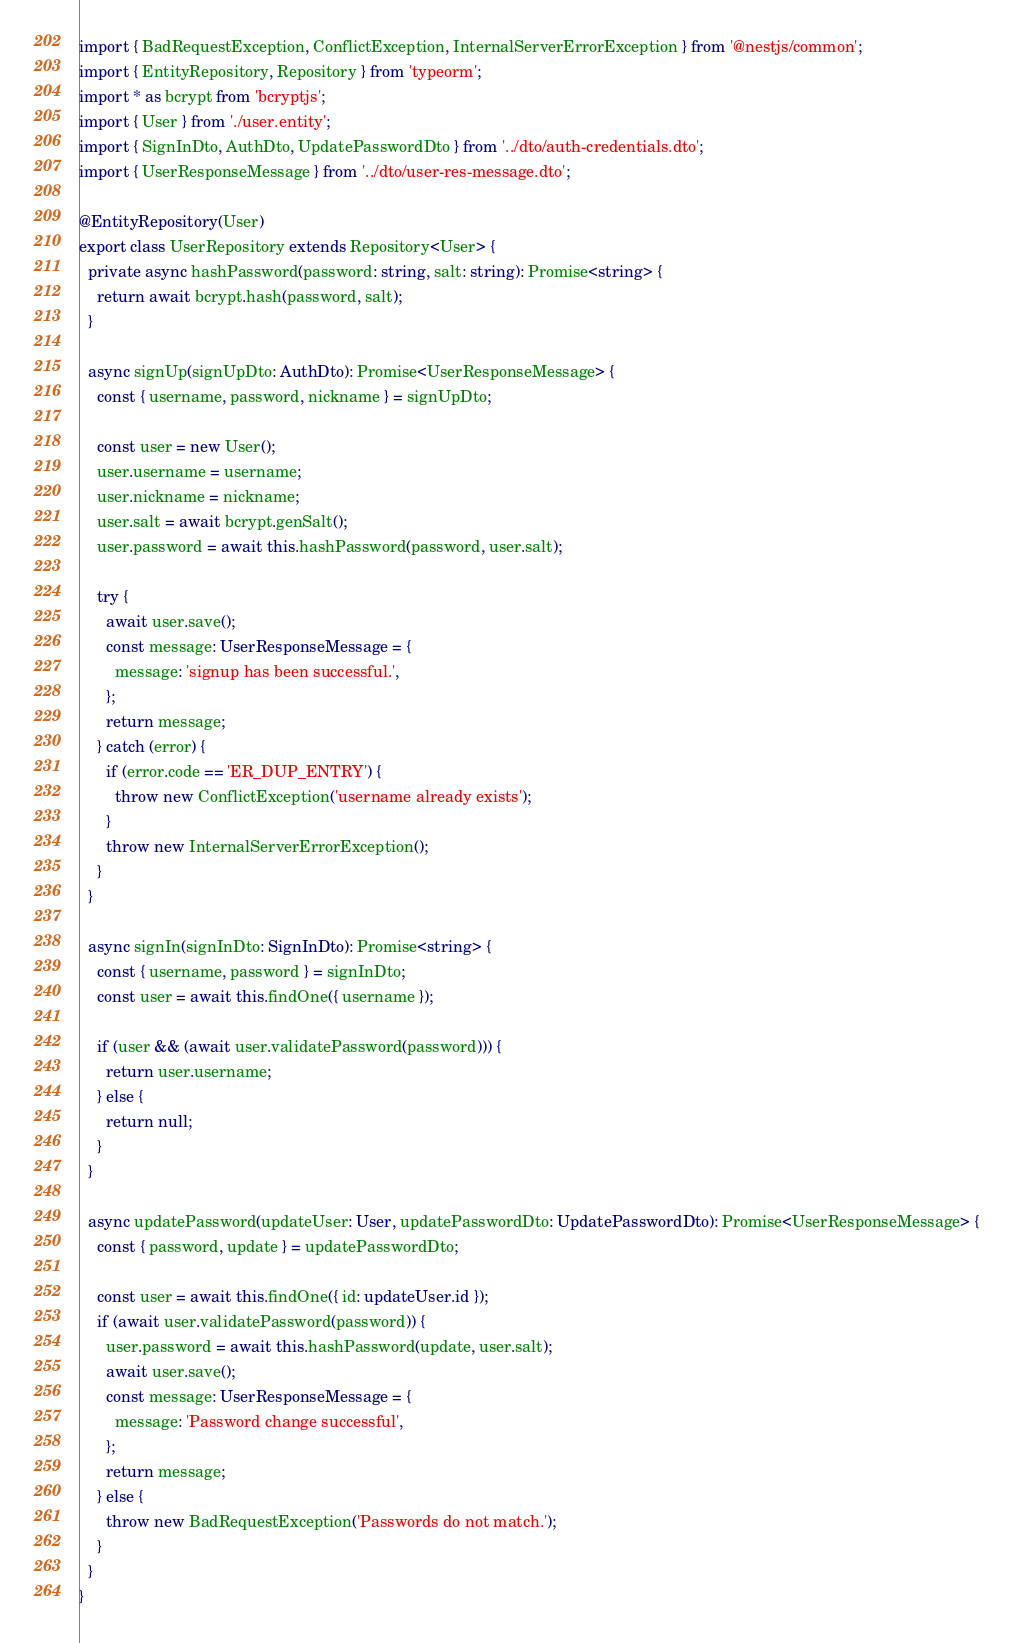<code> <loc_0><loc_0><loc_500><loc_500><_TypeScript_>import { BadRequestException, ConflictException, InternalServerErrorException } from '@nestjs/common';
import { EntityRepository, Repository } from 'typeorm';
import * as bcrypt from 'bcryptjs';
import { User } from './user.entity';
import { SignInDto, AuthDto, UpdatePasswordDto } from '../dto/auth-credentials.dto';
import { UserResponseMessage } from '../dto/user-res-message.dto';

@EntityRepository(User)
export class UserRepository extends Repository<User> {
  private async hashPassword(password: string, salt: string): Promise<string> {
    return await bcrypt.hash(password, salt);
  }

  async signUp(signUpDto: AuthDto): Promise<UserResponseMessage> {
    const { username, password, nickname } = signUpDto;

    const user = new User();
    user.username = username;
    user.nickname = nickname;
    user.salt = await bcrypt.genSalt();
    user.password = await this.hashPassword(password, user.salt);

    try {
      await user.save();
      const message: UserResponseMessage = {
        message: 'signup has been successful.',
      };
      return message;
    } catch (error) {
      if (error.code == 'ER_DUP_ENTRY') {
        throw new ConflictException('username already exists');
      }
      throw new InternalServerErrorException();
    }
  }

  async signIn(signInDto: SignInDto): Promise<string> {
    const { username, password } = signInDto;
    const user = await this.findOne({ username });

    if (user && (await user.validatePassword(password))) {
      return user.username;
    } else {
      return null;
    }
  }

  async updatePassword(updateUser: User, updatePasswordDto: UpdatePasswordDto): Promise<UserResponseMessage> {
    const { password, update } = updatePasswordDto;

    const user = await this.findOne({ id: updateUser.id });
    if (await user.validatePassword(password)) {
      user.password = await this.hashPassword(update, user.salt);
      await user.save();
      const message: UserResponseMessage = {
        message: 'Password change successful',
      };
      return message;
    } else {
      throw new BadRequestException('Passwords do not match.');
    }
  }
}
</code> 